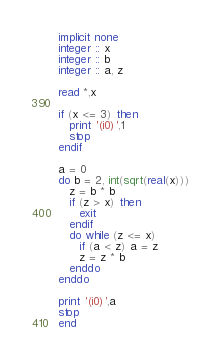<code> <loc_0><loc_0><loc_500><loc_500><_FORTRAN_>implicit none
integer :: x
integer :: b
integer :: a, z

read *,x

if (x <= 3) then
   print '(i0)',1
   stop
endif

a = 0
do b = 2, int(sqrt(real(x)))
   z = b * b
   if (z > x) then
      exit
   endif
   do while (z <= x)
      if (a < z) a = z
      z = z * b
   enddo
enddo

print '(i0)',a
stop
end  </code> 